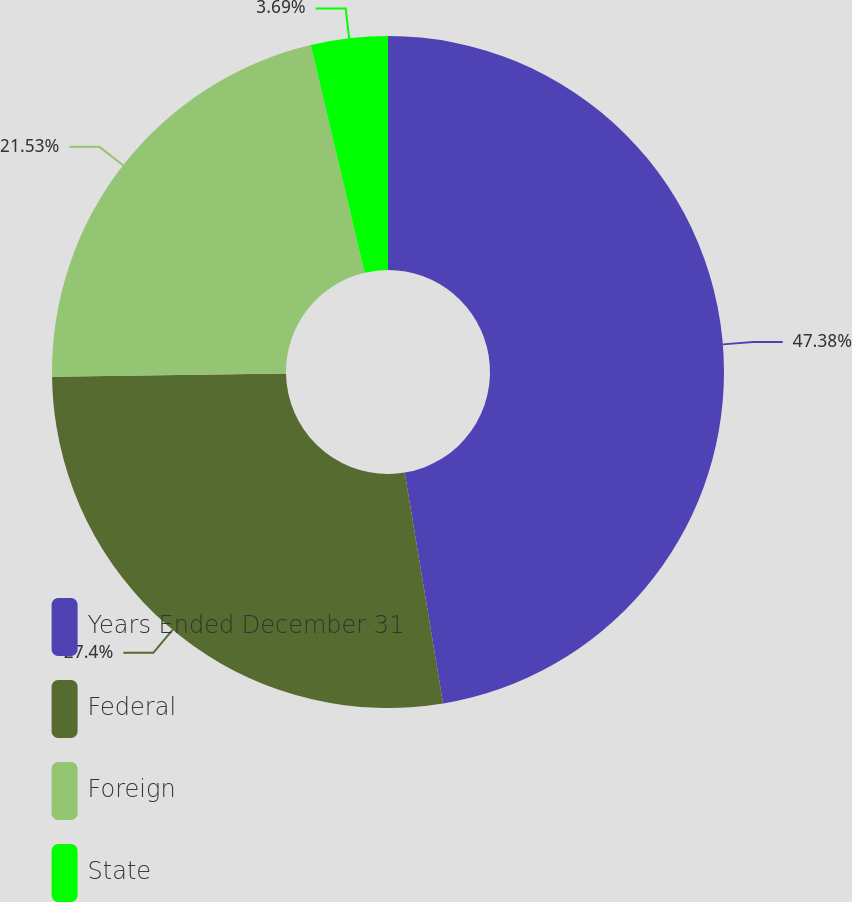<chart> <loc_0><loc_0><loc_500><loc_500><pie_chart><fcel>Years Ended December 31<fcel>Federal<fcel>Foreign<fcel>State<nl><fcel>47.38%<fcel>27.4%<fcel>21.53%<fcel>3.69%<nl></chart> 